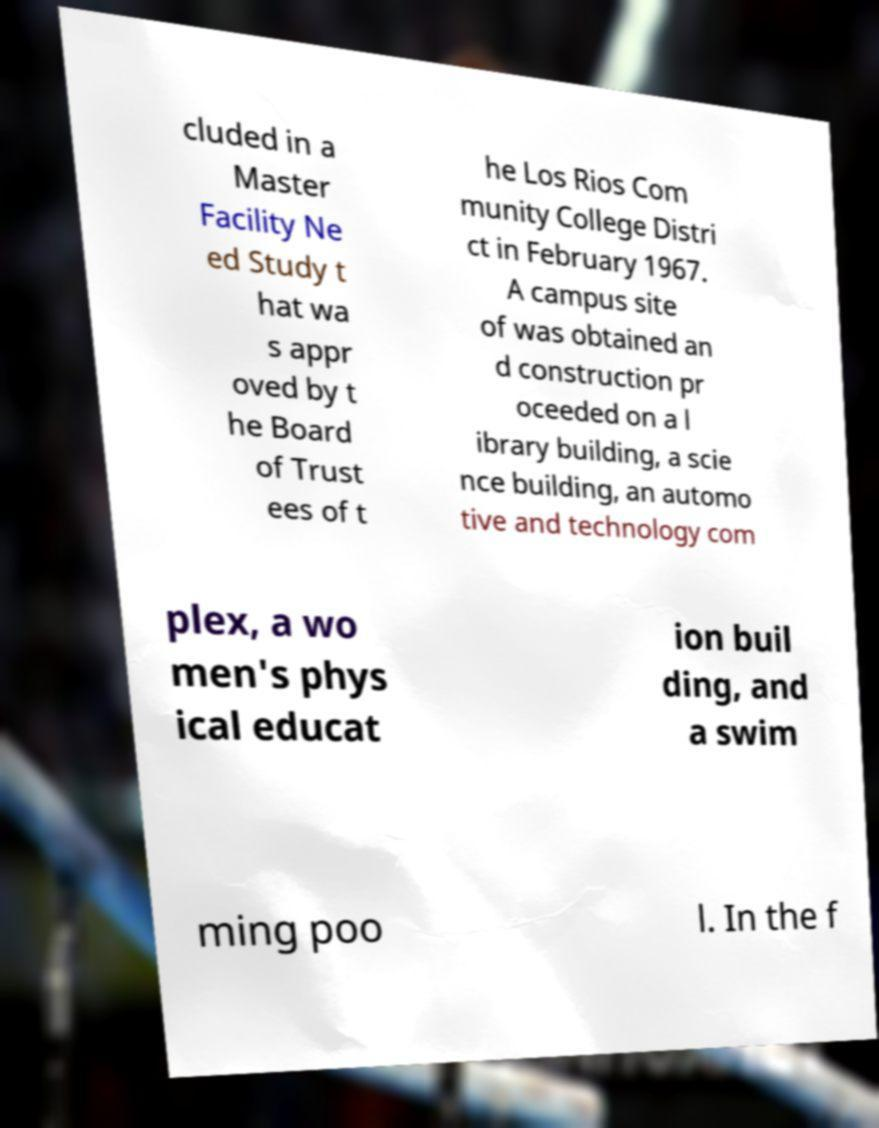Please identify and transcribe the text found in this image. cluded in a Master Facility Ne ed Study t hat wa s appr oved by t he Board of Trust ees of t he Los Rios Com munity College Distri ct in February 1967. A campus site of was obtained an d construction pr oceeded on a l ibrary building, a scie nce building, an automo tive and technology com plex, a wo men's phys ical educat ion buil ding, and a swim ming poo l. In the f 